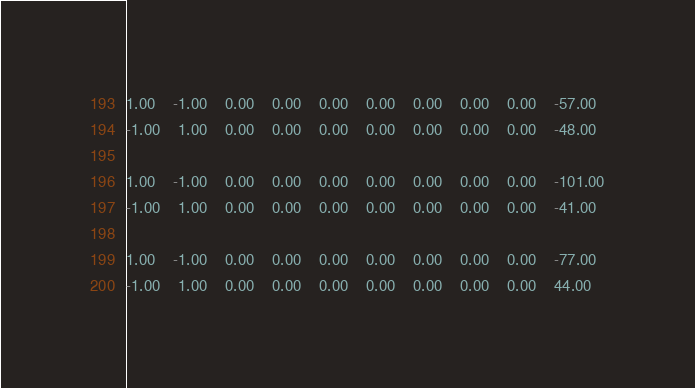<code> <loc_0><loc_0><loc_500><loc_500><_Matlab_>1.00	-1.00	0.00	0.00	0.00	0.00	0.00	0.00	0.00	-57.00
-1.00	1.00	0.00	0.00	0.00	0.00	0.00	0.00	0.00	-48.00

1.00	-1.00	0.00	0.00	0.00	0.00	0.00	0.00	0.00	-101.00
-1.00	1.00	0.00	0.00	0.00	0.00	0.00	0.00	0.00	-41.00

1.00	-1.00	0.00	0.00	0.00	0.00	0.00	0.00	0.00	-77.00
-1.00	1.00	0.00	0.00	0.00	0.00	0.00	0.00	0.00	44.00
</code> 